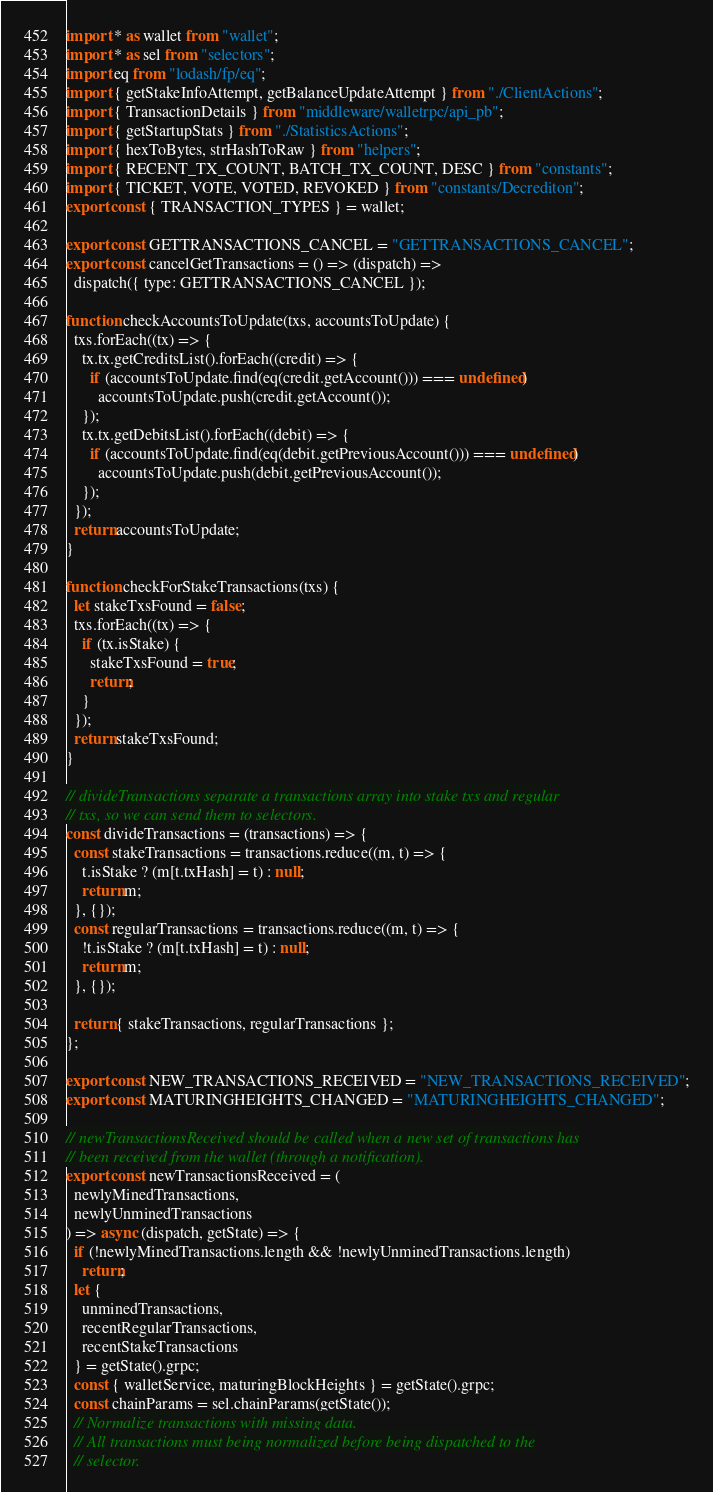<code> <loc_0><loc_0><loc_500><loc_500><_JavaScript_>import * as wallet from "wallet";
import * as sel from "selectors";
import eq from "lodash/fp/eq";
import { getStakeInfoAttempt, getBalanceUpdateAttempt } from "./ClientActions";
import { TransactionDetails } from "middleware/walletrpc/api_pb";
import { getStartupStats } from "./StatisticsActions";
import { hexToBytes, strHashToRaw } from "helpers";
import { RECENT_TX_COUNT, BATCH_TX_COUNT, DESC } from "constants";
import { TICKET, VOTE, VOTED, REVOKED } from "constants/Decrediton";
export const { TRANSACTION_TYPES } = wallet;

export const GETTRANSACTIONS_CANCEL = "GETTRANSACTIONS_CANCEL";
export const cancelGetTransactions = () => (dispatch) =>
  dispatch({ type: GETTRANSACTIONS_CANCEL });

function checkAccountsToUpdate(txs, accountsToUpdate) {
  txs.forEach((tx) => {
    tx.tx.getCreditsList().forEach((credit) => {
      if (accountsToUpdate.find(eq(credit.getAccount())) === undefined)
        accountsToUpdate.push(credit.getAccount());
    });
    tx.tx.getDebitsList().forEach((debit) => {
      if (accountsToUpdate.find(eq(debit.getPreviousAccount())) === undefined)
        accountsToUpdate.push(debit.getPreviousAccount());
    });
  });
  return accountsToUpdate;
}

function checkForStakeTransactions(txs) {
  let stakeTxsFound = false;
  txs.forEach((tx) => {
    if (tx.isStake) {
      stakeTxsFound = true;
      return;
    }
  });
  return stakeTxsFound;
}

// divideTransactions separate a transactions array into stake txs and regular
// txs, so we can send them to selectors.
const divideTransactions = (transactions) => {
  const stakeTransactions = transactions.reduce((m, t) => {
    t.isStake ? (m[t.txHash] = t) : null;
    return m;
  }, {});
  const regularTransactions = transactions.reduce((m, t) => {
    !t.isStake ? (m[t.txHash] = t) : null;
    return m;
  }, {});

  return { stakeTransactions, regularTransactions };
};

export const NEW_TRANSACTIONS_RECEIVED = "NEW_TRANSACTIONS_RECEIVED";
export const MATURINGHEIGHTS_CHANGED = "MATURINGHEIGHTS_CHANGED";

// newTransactionsReceived should be called when a new set of transactions has
// been received from the wallet (through a notification).
export const newTransactionsReceived = (
  newlyMinedTransactions,
  newlyUnminedTransactions
) => async (dispatch, getState) => {
  if (!newlyMinedTransactions.length && !newlyUnminedTransactions.length)
    return;
  let {
    unminedTransactions,
    recentRegularTransactions,
    recentStakeTransactions
  } = getState().grpc;
  const { walletService, maturingBlockHeights } = getState().grpc;
  const chainParams = sel.chainParams(getState());
  // Normalize transactions with missing data.
  // All transactions must being normalized before being dispatched to the
  // selector.</code> 